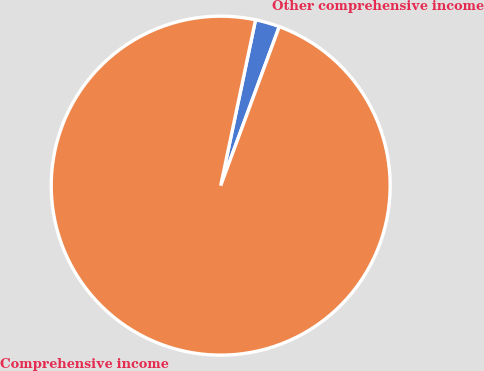Convert chart. <chart><loc_0><loc_0><loc_500><loc_500><pie_chart><fcel>Other comprehensive income<fcel>Comprehensive income<nl><fcel>2.32%<fcel>97.68%<nl></chart> 